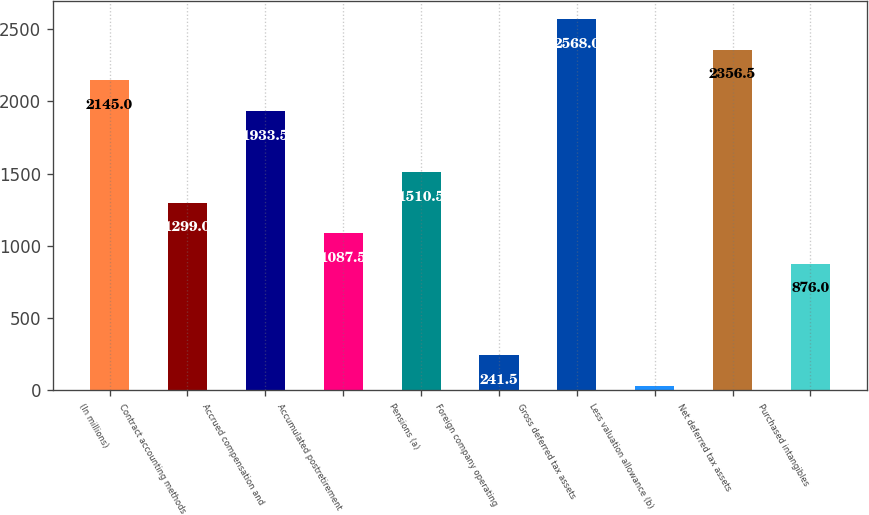Convert chart. <chart><loc_0><loc_0><loc_500><loc_500><bar_chart><fcel>(In millions)<fcel>Contract accounting methods<fcel>Accrued compensation and<fcel>Accumulated postretirement<fcel>Pensions (a)<fcel>Foreign company operating<fcel>Gross deferred tax assets<fcel>Less valuation allowance (b)<fcel>Net deferred tax assets<fcel>Purchased intangibles<nl><fcel>2145<fcel>1299<fcel>1933.5<fcel>1087.5<fcel>1510.5<fcel>241.5<fcel>2568<fcel>30<fcel>2356.5<fcel>876<nl></chart> 